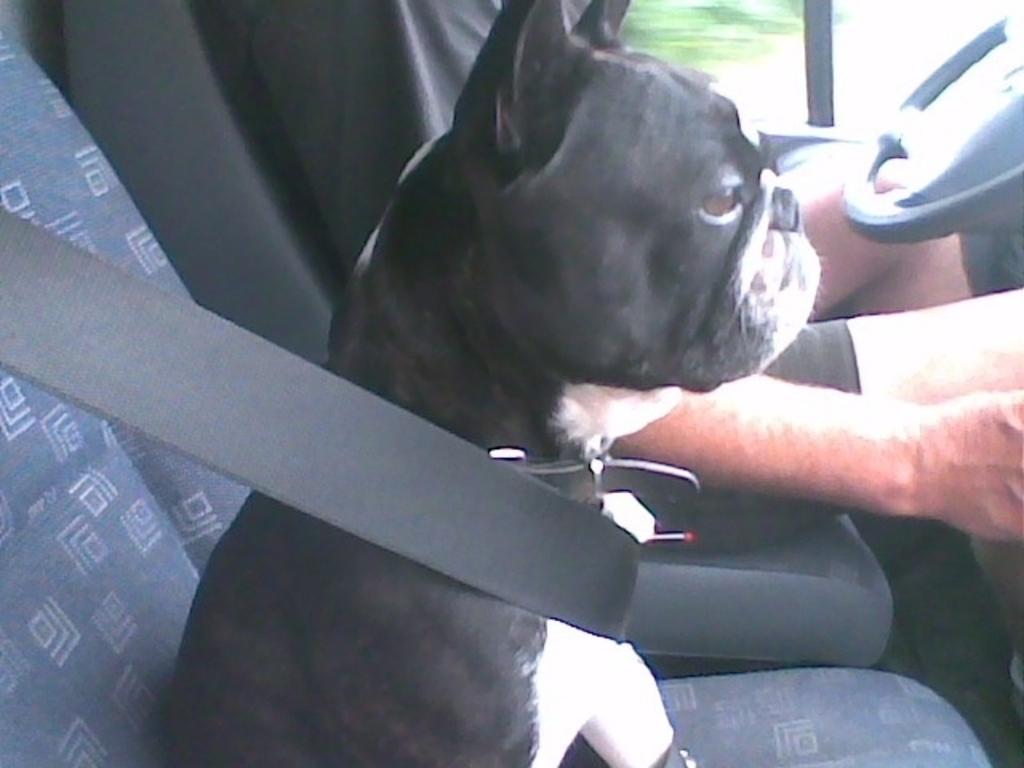How would you summarize this image in a sentence or two? In the image in the center there is a car. In the car,we can see one person sitting. And there is a steering wheel,seat belt and one dog,which is in black and white color. 